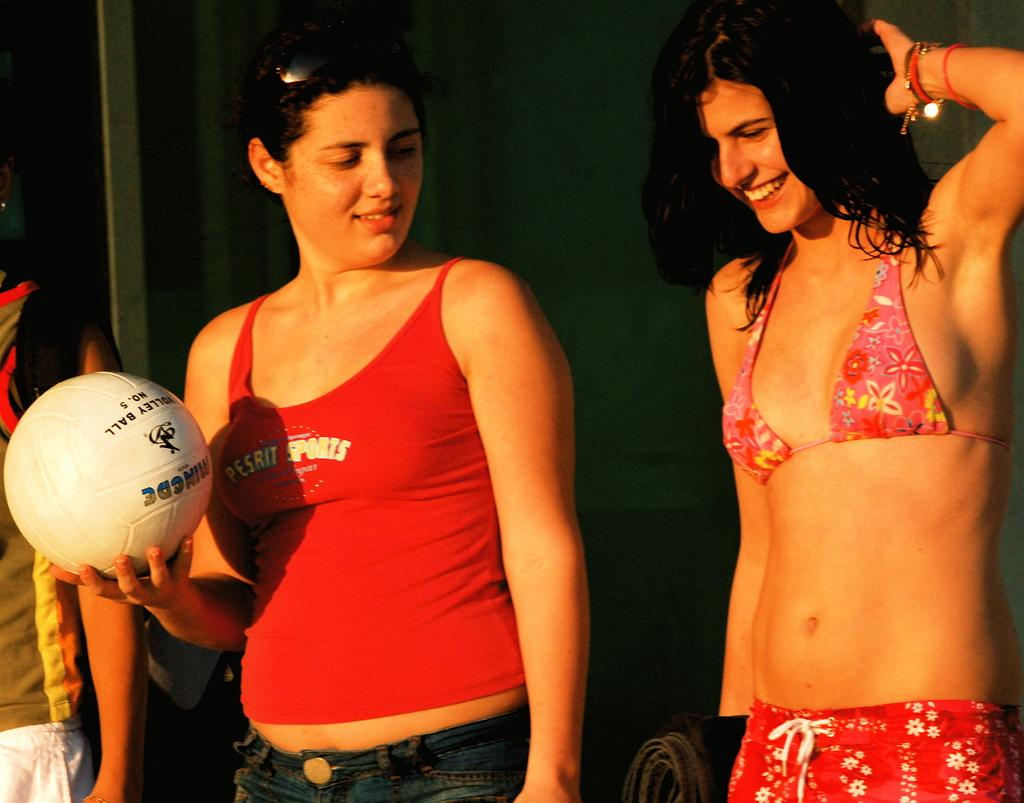What is the girl doing in the image? The girl is standing and laughing in the image. On which side of the image is the girl located? The girl is on the right side of the image. What is the woman doing in the image? The woman is holding a football in the image. On which side of the image is the woman located? The woman is on the left side of the image. What type of boats can be seen in the image? There are no boats present in the image. What rhythm is the girl dancing to in the image? The girl is not dancing in the image; she is simply laughing. 